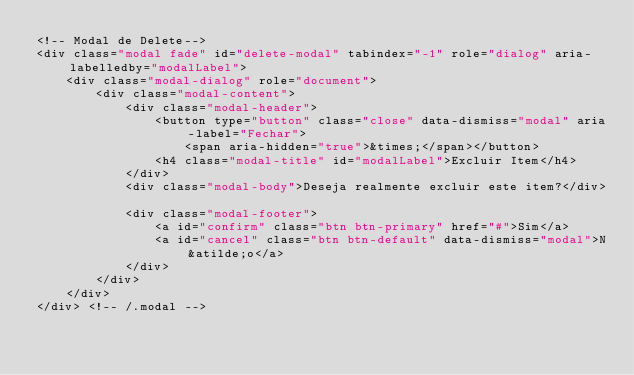Convert code to text. <code><loc_0><loc_0><loc_500><loc_500><_PHP_><!-- Modal de Delete-->	
<div class="modal fade" id="delete-modal" tabindex="-1" role="dialog" aria-labelledby="modalLabel">	  
    <div class="modal-dialog" role="document">	    
        <div class="modal-content">	      
            <div class="modal-header">	        
                <button type="button" class="close" data-dismiss="modal" aria-label="Fechar">
                    <span aria-hidden="true">&times;</span></button>	        
                <h4 class="modal-title" id="modalLabel">Excluir Item</h4>	      
            </div>	      
            <div class="modal-body">Deseja realmente excluir este item?</div>	      
            <div class="modal-footer">	        
                <a id="confirm" class="btn btn-primary" href="#">Sim</a>
                <a id="cancel" class="btn btn-default" data-dismiss="modal">N&atilde;o</a>	      
            </div>	    
        </div>	  
    </div>	
</div> <!-- /.modal --></code> 